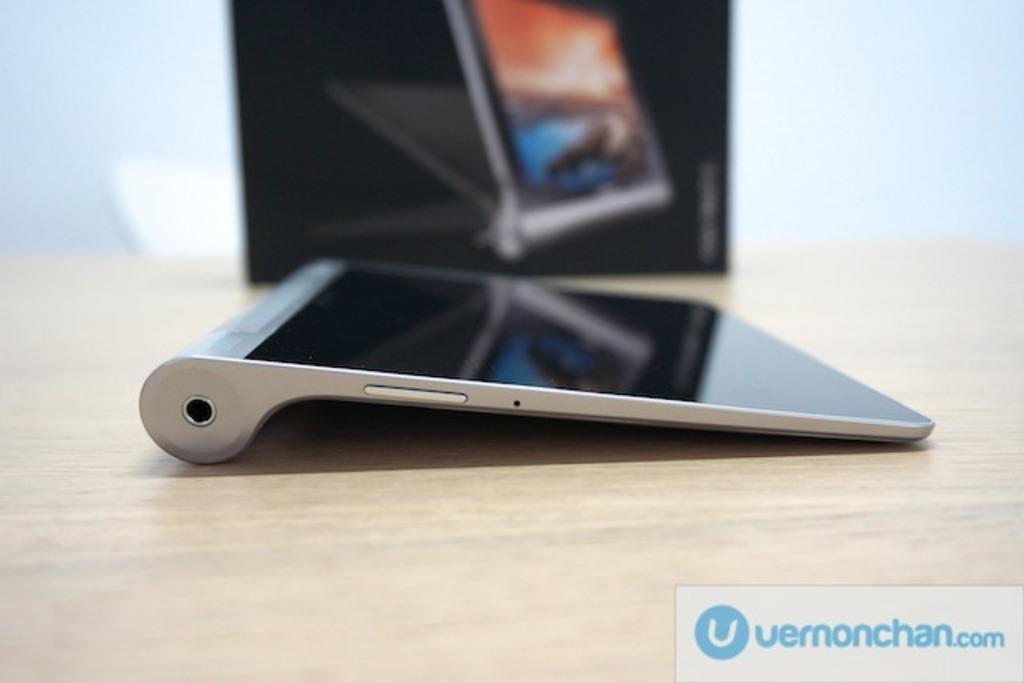Provide a one-sentence caption for the provided image. a touch screen device with the logo for vermonchan.com. 